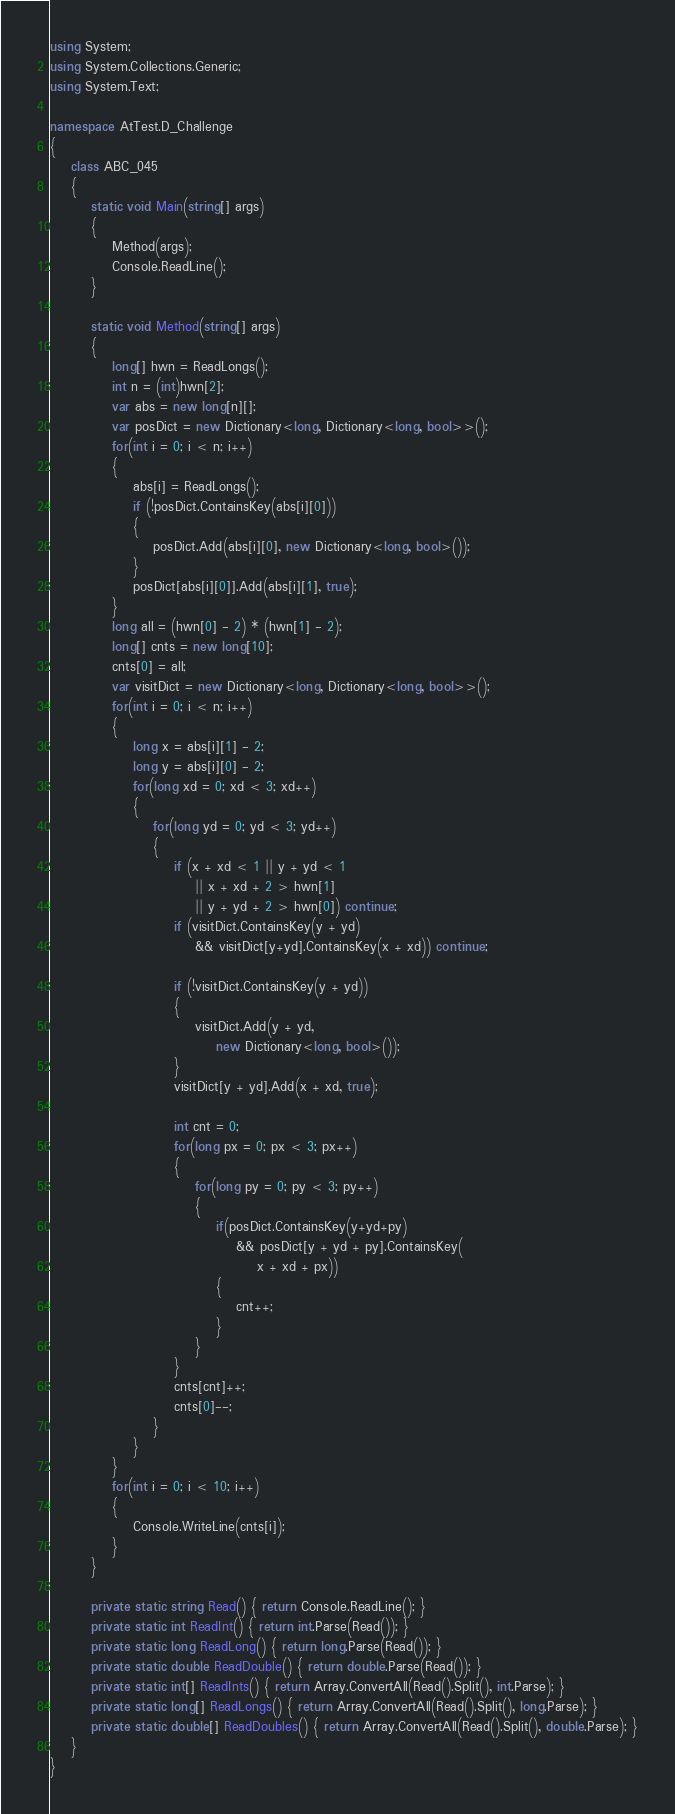Convert code to text. <code><loc_0><loc_0><loc_500><loc_500><_C#_>using System;
using System.Collections.Generic;
using System.Text;

namespace AtTest.D_Challenge
{
    class ABC_045
    {
        static void Main(string[] args)
        {
            Method(args);
            Console.ReadLine();
        }

        static void Method(string[] args)
        {
            long[] hwn = ReadLongs();
            int n = (int)hwn[2];
            var abs = new long[n][];
            var posDict = new Dictionary<long, Dictionary<long, bool>>();
            for(int i = 0; i < n; i++)
            {
                abs[i] = ReadLongs();
                if (!posDict.ContainsKey(abs[i][0]))
                {
                    posDict.Add(abs[i][0], new Dictionary<long, bool>());
                }
                posDict[abs[i][0]].Add(abs[i][1], true);
            }
            long all = (hwn[0] - 2) * (hwn[1] - 2);
            long[] cnts = new long[10];
            cnts[0] = all;
            var visitDict = new Dictionary<long, Dictionary<long, bool>>();
            for(int i = 0; i < n; i++)
            {
                long x = abs[i][1] - 2;
                long y = abs[i][0] - 2;
                for(long xd = 0; xd < 3; xd++)
                {
                    for(long yd = 0; yd < 3; yd++)
                    {
                        if (x + xd < 1 || y + yd < 1
                            || x + xd + 2 > hwn[1]
                            || y + yd + 2 > hwn[0]) continue;
                        if (visitDict.ContainsKey(y + yd)
                            && visitDict[y+yd].ContainsKey(x + xd)) continue;

                        if (!visitDict.ContainsKey(y + yd))
                        {
                            visitDict.Add(y + yd,
                                new Dictionary<long, bool>());
                        }
                        visitDict[y + yd].Add(x + xd, true);

                        int cnt = 0;
                        for(long px = 0; px < 3; px++)
                        {
                            for(long py = 0; py < 3; py++)
                            {
                                if(posDict.ContainsKey(y+yd+py)
                                    && posDict[y + yd + py].ContainsKey(
                                        x + xd + px))
                                {
                                    cnt++;
                                }
                            }
                        }
                        cnts[cnt]++;
                        cnts[0]--;
                    }
                }
            }
            for(int i = 0; i < 10; i++)
            {
                Console.WriteLine(cnts[i]);
            }
        }

        private static string Read() { return Console.ReadLine(); }
        private static int ReadInt() { return int.Parse(Read()); }
        private static long ReadLong() { return long.Parse(Read()); }
        private static double ReadDouble() { return double.Parse(Read()); }
        private static int[] ReadInts() { return Array.ConvertAll(Read().Split(), int.Parse); }
        private static long[] ReadLongs() { return Array.ConvertAll(Read().Split(), long.Parse); }
        private static double[] ReadDoubles() { return Array.ConvertAll(Read().Split(), double.Parse); }
    }
}
</code> 